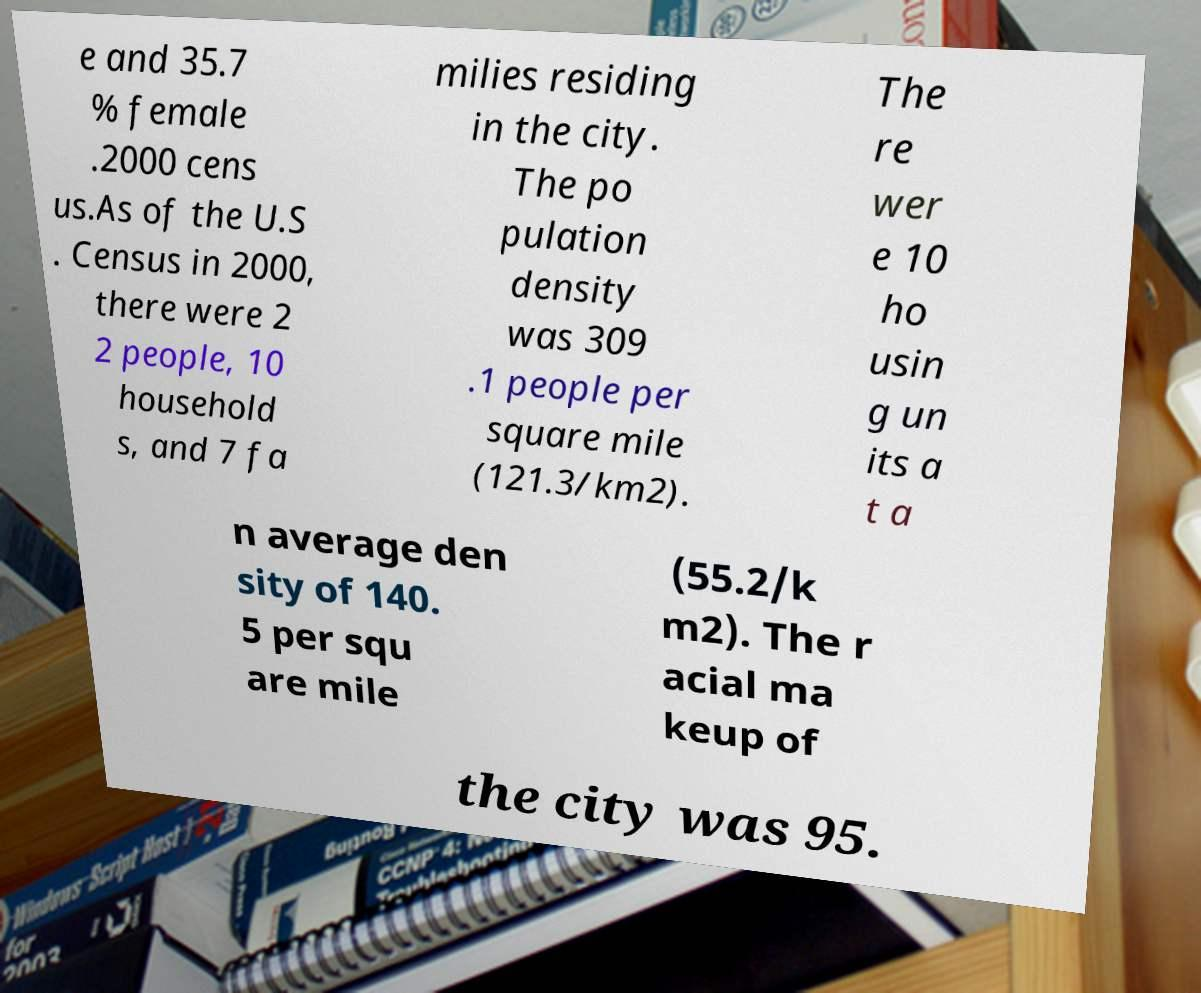Please read and relay the text visible in this image. What does it say? e and 35.7 % female .2000 cens us.As of the U.S . Census in 2000, there were 2 2 people, 10 household s, and 7 fa milies residing in the city. The po pulation density was 309 .1 people per square mile (121.3/km2). The re wer e 10 ho usin g un its a t a n average den sity of 140. 5 per squ are mile (55.2/k m2). The r acial ma keup of the city was 95. 